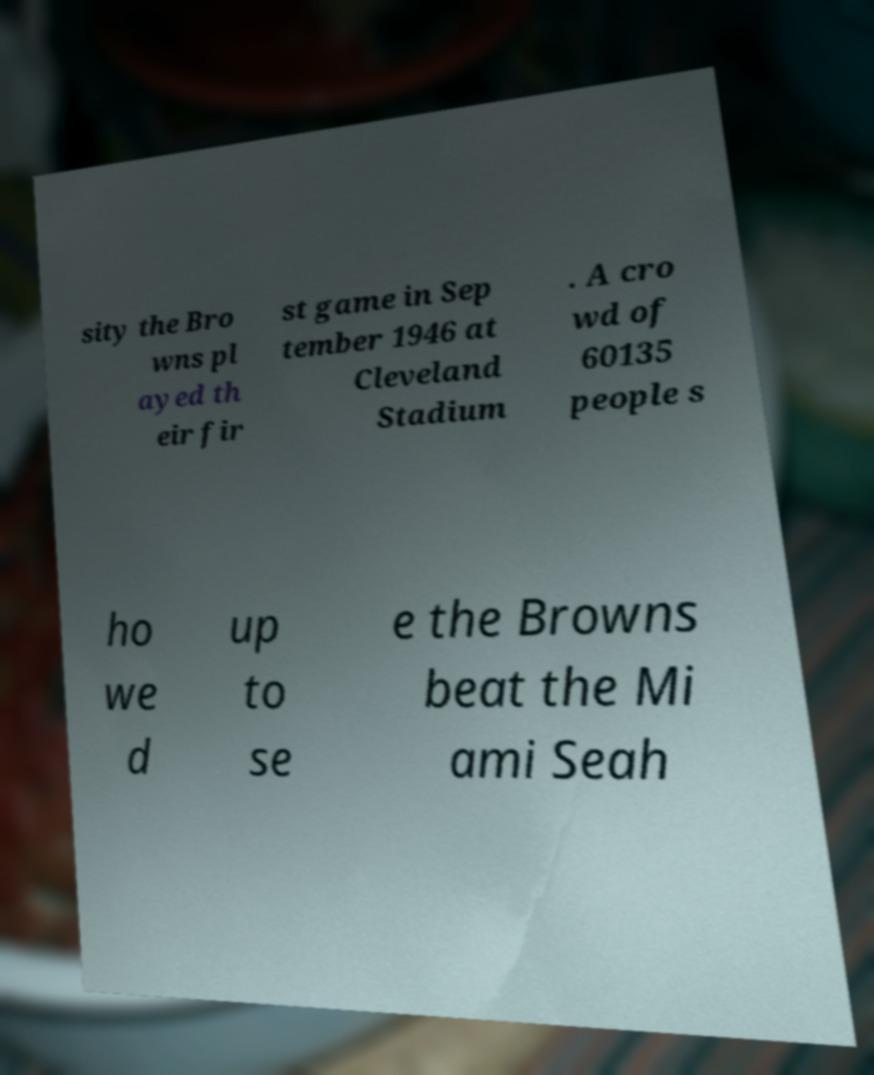Can you accurately transcribe the text from the provided image for me? sity the Bro wns pl ayed th eir fir st game in Sep tember 1946 at Cleveland Stadium . A cro wd of 60135 people s ho we d up to se e the Browns beat the Mi ami Seah 